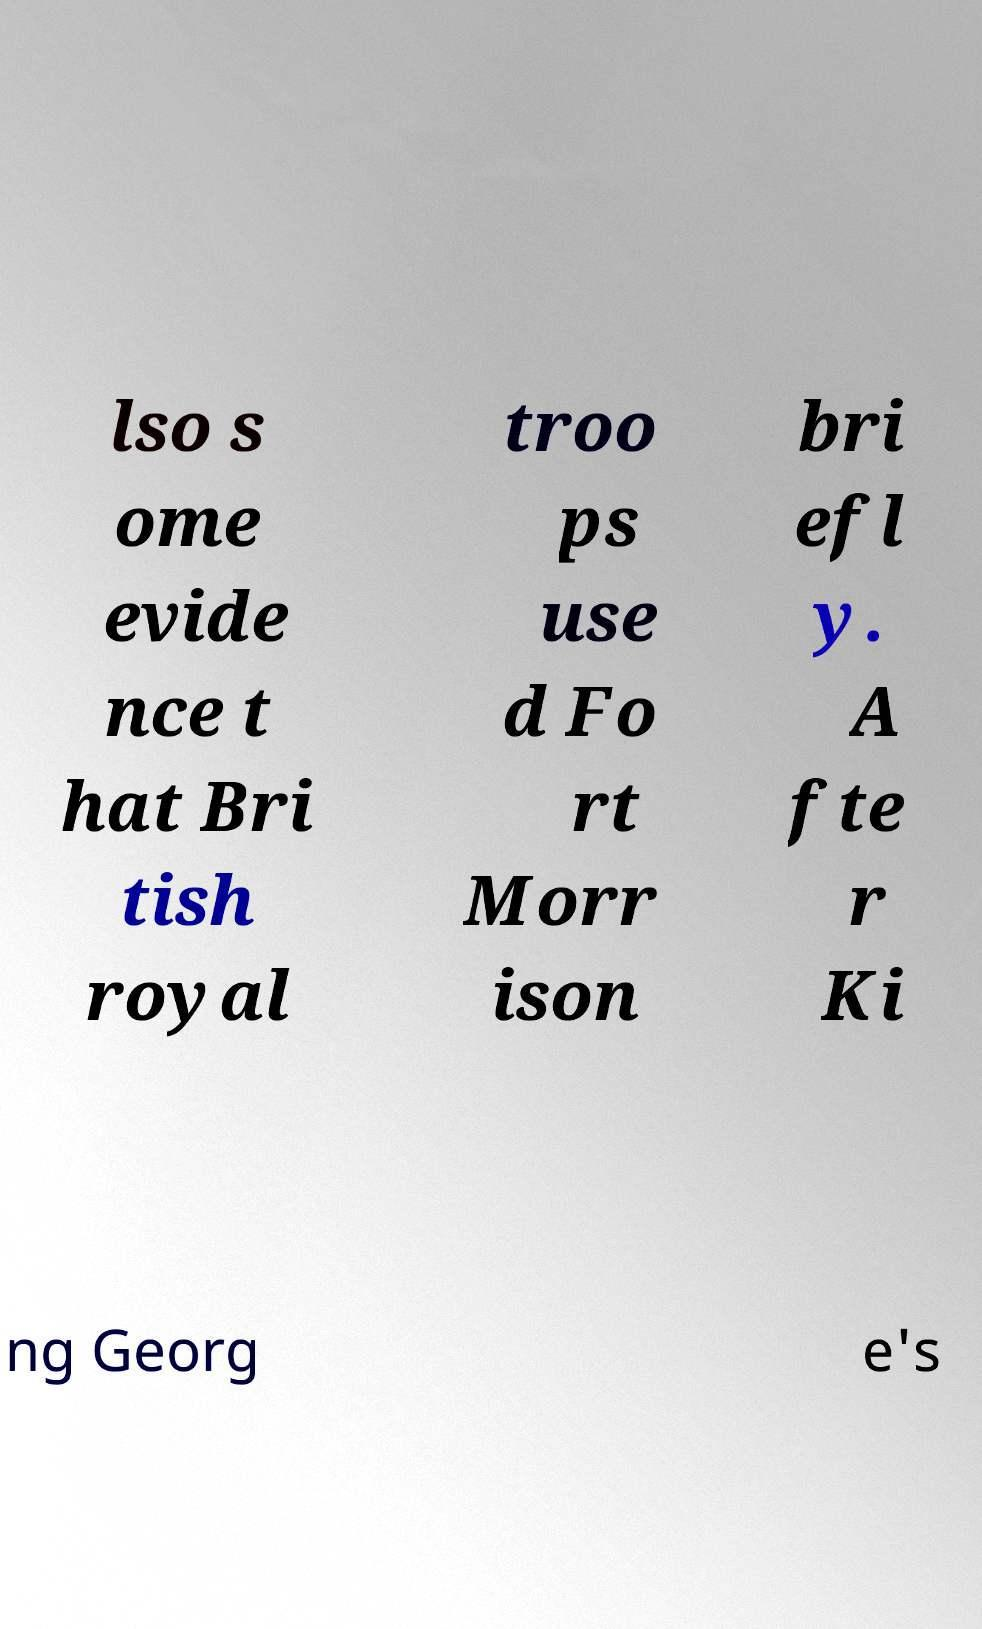Please read and relay the text visible in this image. What does it say? lso s ome evide nce t hat Bri tish royal troo ps use d Fo rt Morr ison bri efl y. A fte r Ki ng Georg e's 